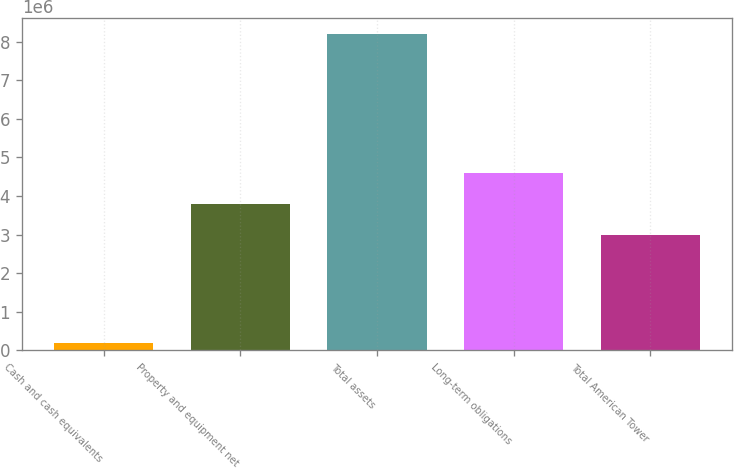<chart> <loc_0><loc_0><loc_500><loc_500><bar_chart><fcel>Cash and cash equivalents<fcel>Property and equipment net<fcel>Total assets<fcel>Long-term obligations<fcel>Total American Tower<nl><fcel>194943<fcel>3.79299e+06<fcel>8.21166e+06<fcel>4.59467e+06<fcel>2.99132e+06<nl></chart> 